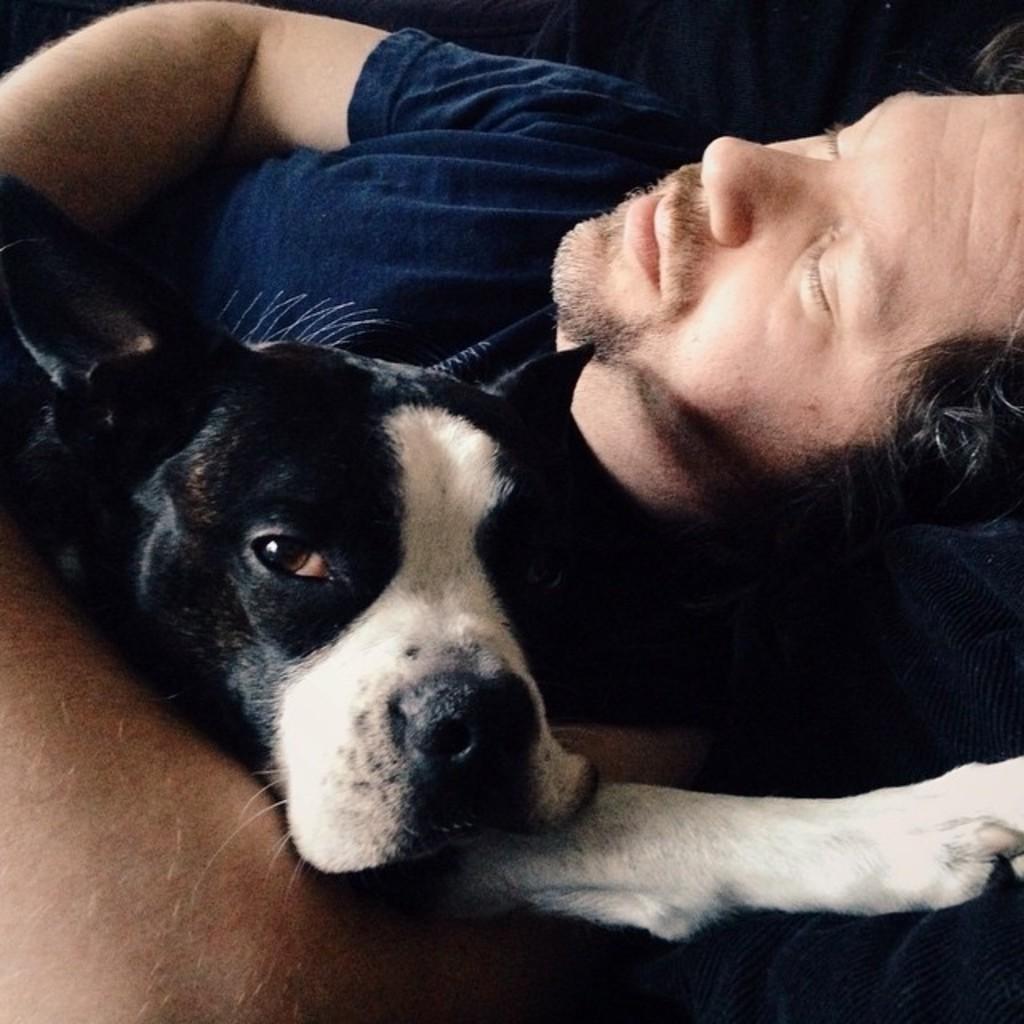Can you describe this image briefly? In this picture a guy is sleeping on a sofa with a dog in his hand. 